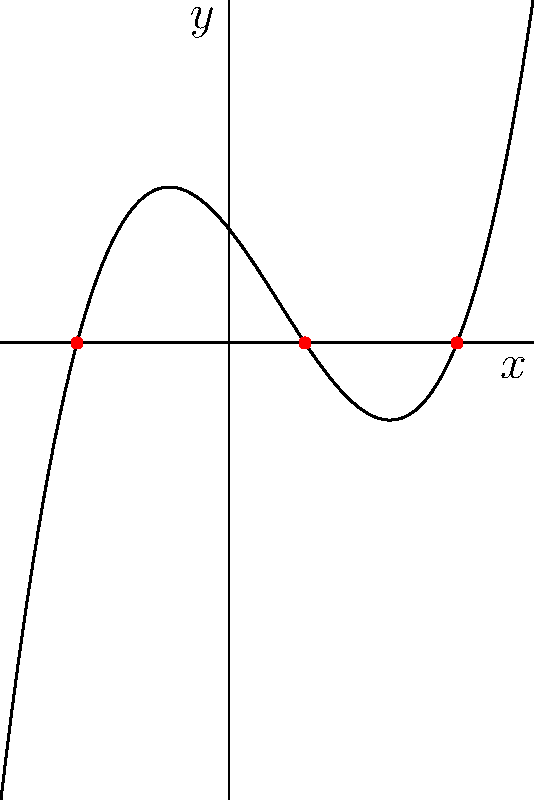Given the graph of a polynomial function $f(x)$, determine its roots and express the function in factored form. What is the degree of this polynomial? To solve this problem, let's follow these steps:

1. Identify the roots:
   The roots of a polynomial are the x-intercepts of its graph. From the given graph, we can see that the curve crosses the x-axis at three points: $x = -2$, $x = 1$, and $x = 3$.

2. Express the function in factored form:
   Since we have identified the roots, we can express the polynomial as:
   $f(x) = a(x+2)(x-1)(x-3)$
   where $a$ is a constant that determines the vertical stretch of the graph.

3. Determine the degree of the polynomial:
   The degree of a polynomial is equal to the highest power of the variable. In the factored form, we have three linear factors. When multiplied out, this will result in a cubic polynomial (degree 3).

4. Verify the shape of the graph:
   The graph starts in the second quadrant, passes through the third and fourth quadrants, and ends in the first quadrant. This behavior is consistent with a cubic function.

Therefore, we can conclude that this is a cubic polynomial (degree 3) with roots at $x = -2$, $x = 1$, and $x = 3$.
Answer: Cubic polynomial (degree 3) with roots at $x = -2$, $x = 1$, and $x = 3$ 